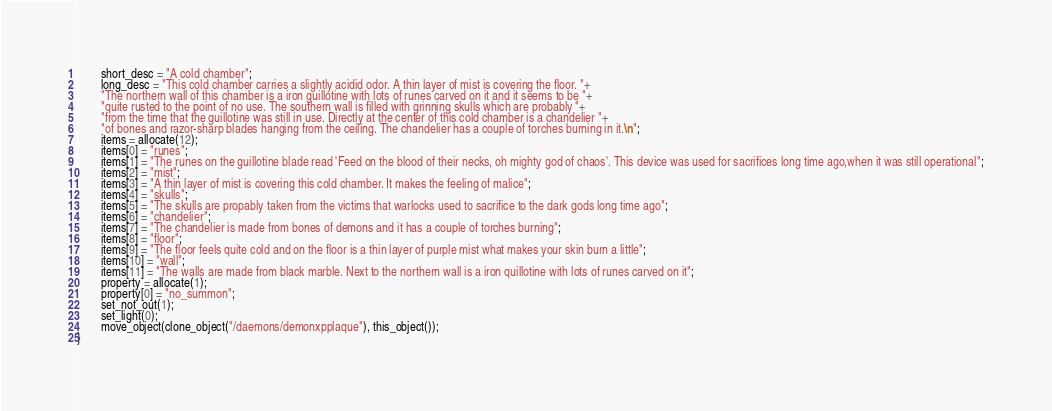<code> <loc_0><loc_0><loc_500><loc_500><_C_>        short_desc = "A cold chamber";
        long_desc = "This cold chamber carries a slightly acidid odor. A thin layer of mist is covering the floor. "+
        "The northern wall of this chamber is a iron guillotine with lots of runes carved on it and it seems to be "+
        "quite rusted to the point of no use. The southern wall is filled with grinning skulls which are probably "+
        "from the time that the guillotine was still in use. Directly at the center of this cold chamber is a chandelier "+
        "of bones and razor-sharp blades hanging from the ceiling. The chandelier has a couple of torches burning in it.\n";
        items = allocate(12);
        items[0] = "runes";
        items[1] = "The runes on the guillotine blade read 'Feed on the blood of their necks, oh mighty god of chaos'. This device was used for sacrifices long time ago,when it was still operational";
        items[2] = "mist";
        items[3] = "A thin layer of mist is covering this cold chamber. It makes the feeling of malice";
        items[4] = "skulls";
        items[5] = "The skulls are propably taken from the victims that warlocks used to sacrifice to the dark gods long time ago";
        items[6] = "chandelier";
        items[7] = "The chandelier is made from bones of demons and it has a couple of torches burning";
        items[8] = "floor";
        items[9] = "The floor feels quite cold and on the floor is a thin layer of purple mist what makes your skin burn a little";
        items[10] = "wall";
        items[11] = "The walls are made from black marble. Next to the northern wall is a iron quillotine with lots of runes carved on it";
        property = allocate(1);
        property[0] = "no_summon";
        set_not_out(1);
        set_light(0);
        move_object(clone_object("/daemons/demonxpplaque"), this_object());
}

</code> 